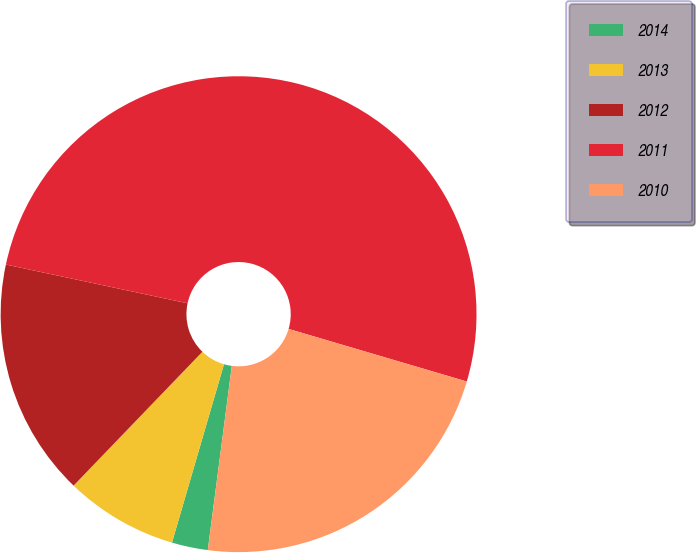Convert chart to OTSL. <chart><loc_0><loc_0><loc_500><loc_500><pie_chart><fcel>2014<fcel>2013<fcel>2012<fcel>2011<fcel>2010<nl><fcel>2.45%<fcel>7.68%<fcel>16.15%<fcel>51.22%<fcel>22.5%<nl></chart> 